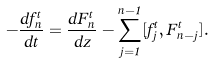<formula> <loc_0><loc_0><loc_500><loc_500>- \frac { d f ^ { t } _ { n } } { d t } = \frac { d F ^ { t } _ { n } } { d z } - \sum _ { j = 1 } ^ { n - 1 } [ f ^ { t } _ { j } , F ^ { t } _ { n - j } ] .</formula> 